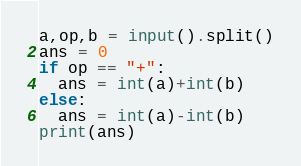<code> <loc_0><loc_0><loc_500><loc_500><_Python_>a,op,b = input().split()
ans = 0
if op == "+":
  ans = int(a)+int(b)
else:
  ans = int(a)-int(b)
print(ans)</code> 